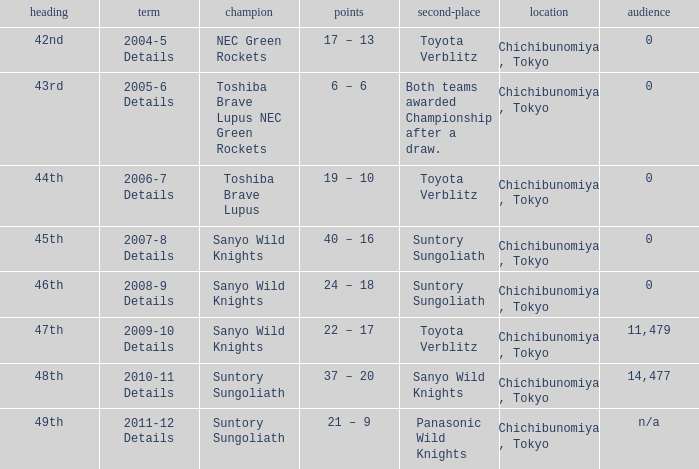What is the Score when the winner was sanyo wild knights, and a Runner-up of suntory sungoliath? 40 – 16, 24 – 18. 